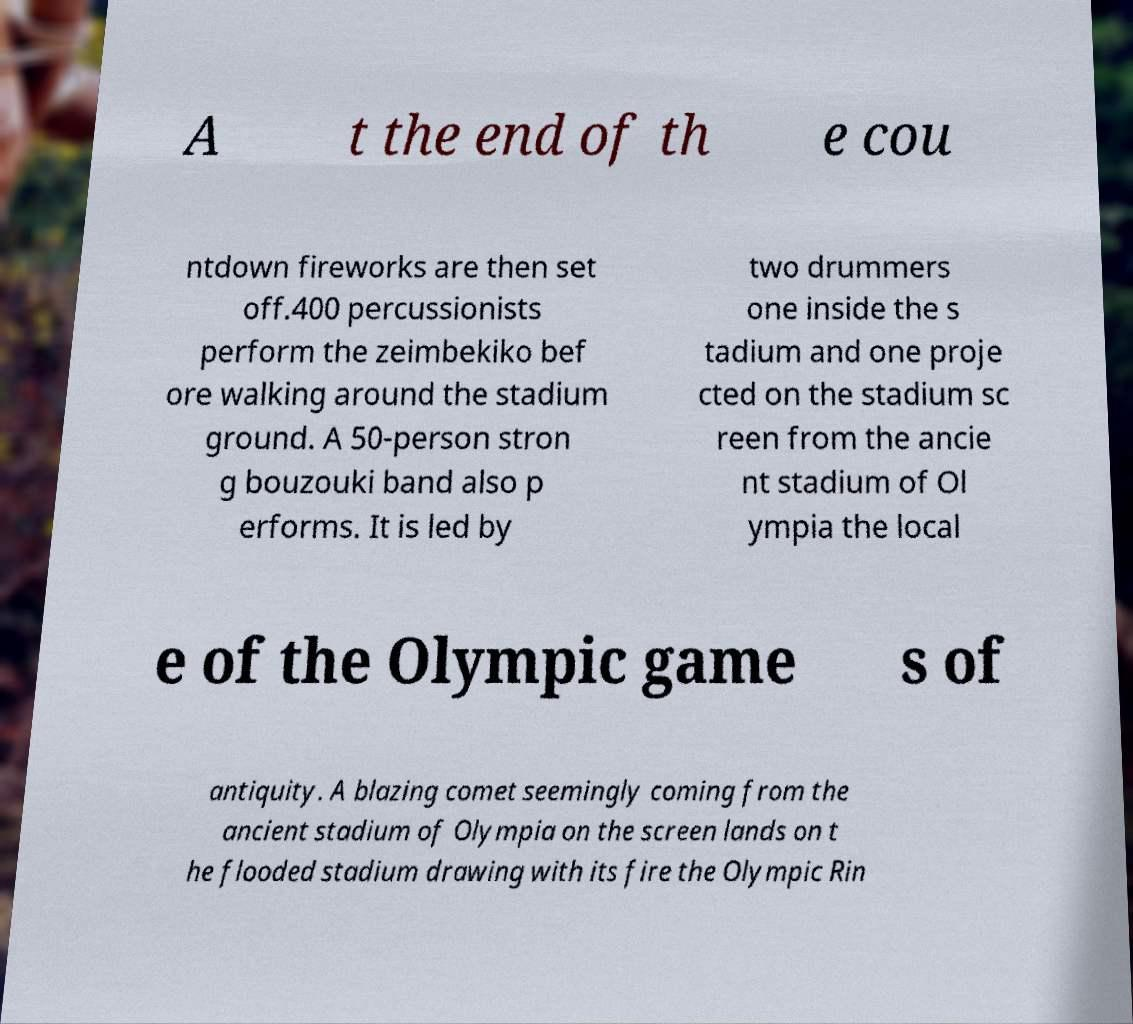Can you read and provide the text displayed in the image?This photo seems to have some interesting text. Can you extract and type it out for me? A t the end of th e cou ntdown fireworks are then set off.400 percussionists perform the zeimbekiko bef ore walking around the stadium ground. A 50-person stron g bouzouki band also p erforms. It is led by two drummers one inside the s tadium and one proje cted on the stadium sc reen from the ancie nt stadium of Ol ympia the local e of the Olympic game s of antiquity. A blazing comet seemingly coming from the ancient stadium of Olympia on the screen lands on t he flooded stadium drawing with its fire the Olympic Rin 